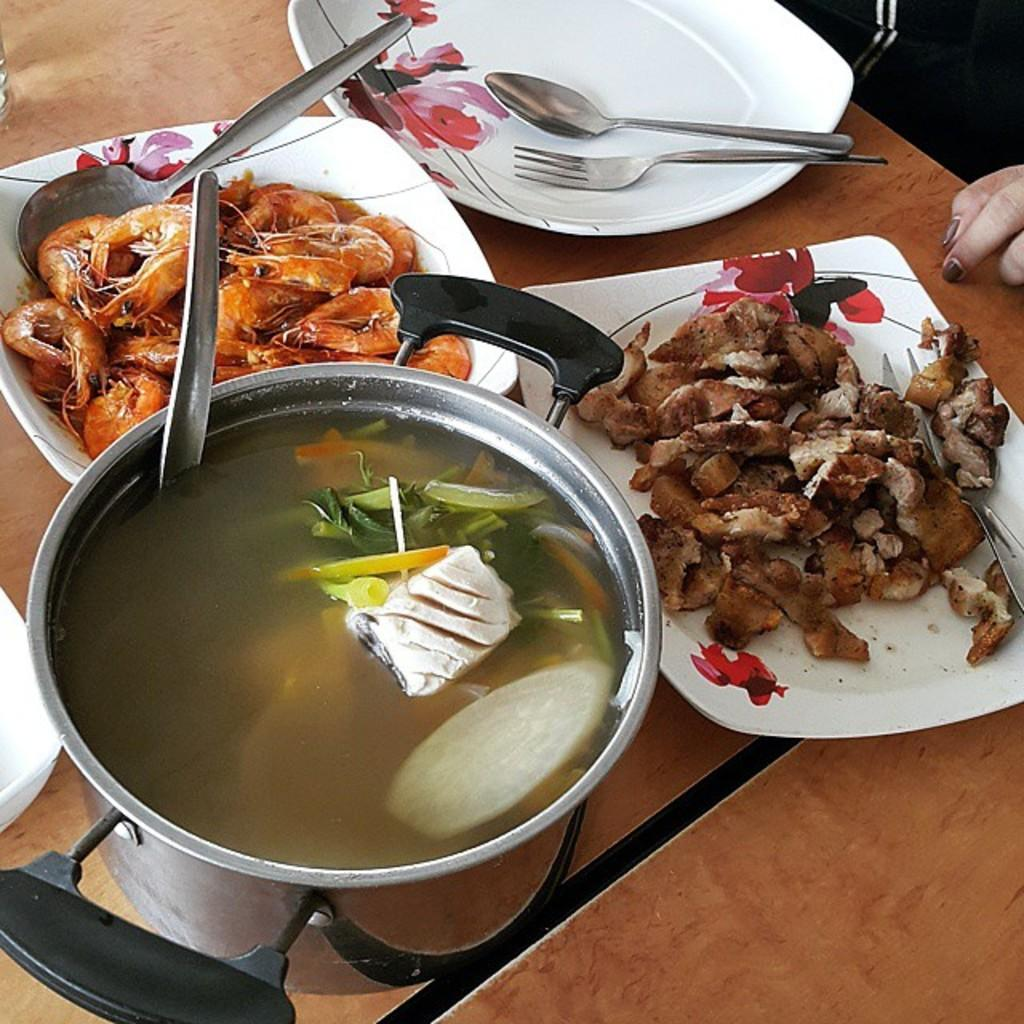What type of food can be seen in the image? There is food in the image, but the specific type is not mentioned. What utensils are present in the image? There are spoons in the image. How are the spoons arranged or placed? The spoons are in plates. What is in the bowl in the image? There is a bowl with water in the image. On what surface is the bowl placed? The bowl is on a table. What is the price of the food in the image? The price of the food is not mentioned in the image, so it cannot be determined. 